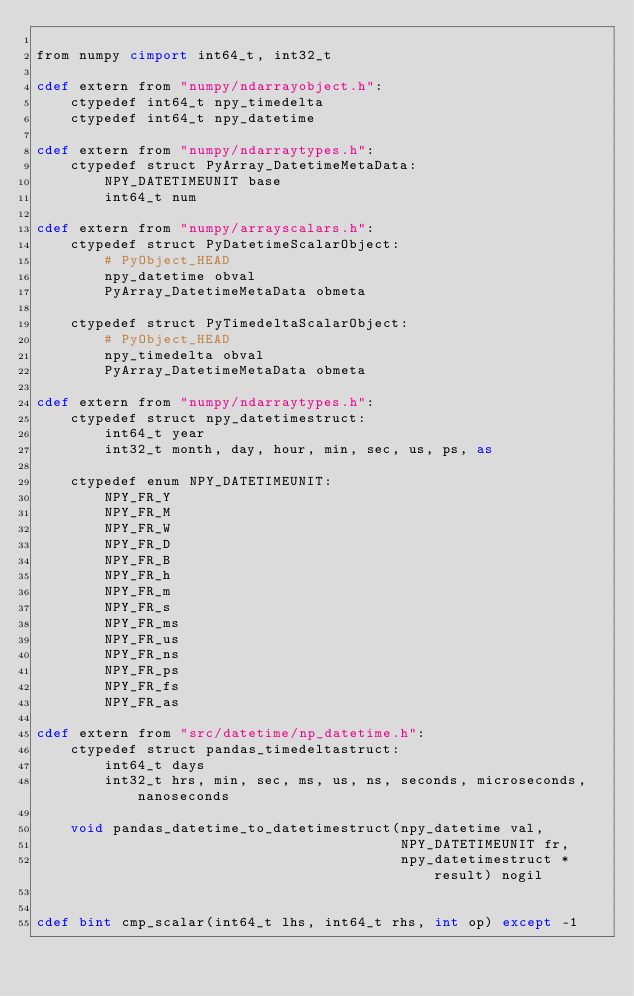Convert code to text. <code><loc_0><loc_0><loc_500><loc_500><_Cython_>
from numpy cimport int64_t, int32_t

cdef extern from "numpy/ndarrayobject.h":
    ctypedef int64_t npy_timedelta
    ctypedef int64_t npy_datetime

cdef extern from "numpy/ndarraytypes.h":
    ctypedef struct PyArray_DatetimeMetaData:
        NPY_DATETIMEUNIT base
        int64_t num

cdef extern from "numpy/arrayscalars.h":
    ctypedef struct PyDatetimeScalarObject:
        # PyObject_HEAD
        npy_datetime obval
        PyArray_DatetimeMetaData obmeta

    ctypedef struct PyTimedeltaScalarObject:
        # PyObject_HEAD
        npy_timedelta obval
        PyArray_DatetimeMetaData obmeta

cdef extern from "numpy/ndarraytypes.h":
    ctypedef struct npy_datetimestruct:
        int64_t year
        int32_t month, day, hour, min, sec, us, ps, as

    ctypedef enum NPY_DATETIMEUNIT:
        NPY_FR_Y
        NPY_FR_M
        NPY_FR_W
        NPY_FR_D
        NPY_FR_B
        NPY_FR_h
        NPY_FR_m
        NPY_FR_s
        NPY_FR_ms
        NPY_FR_us
        NPY_FR_ns
        NPY_FR_ps
        NPY_FR_fs
        NPY_FR_as

cdef extern from "src/datetime/np_datetime.h":
    ctypedef struct pandas_timedeltastruct:
        int64_t days
        int32_t hrs, min, sec, ms, us, ns, seconds, microseconds, nanoseconds

    void pandas_datetime_to_datetimestruct(npy_datetime val,
                                           NPY_DATETIMEUNIT fr,
                                           npy_datetimestruct *result) nogil


cdef bint cmp_scalar(int64_t lhs, int64_t rhs, int op) except -1
</code> 